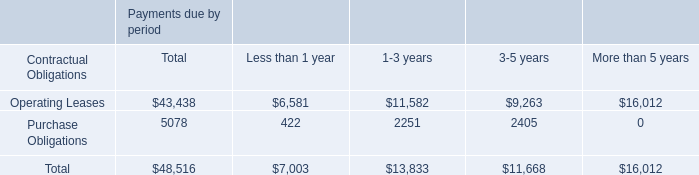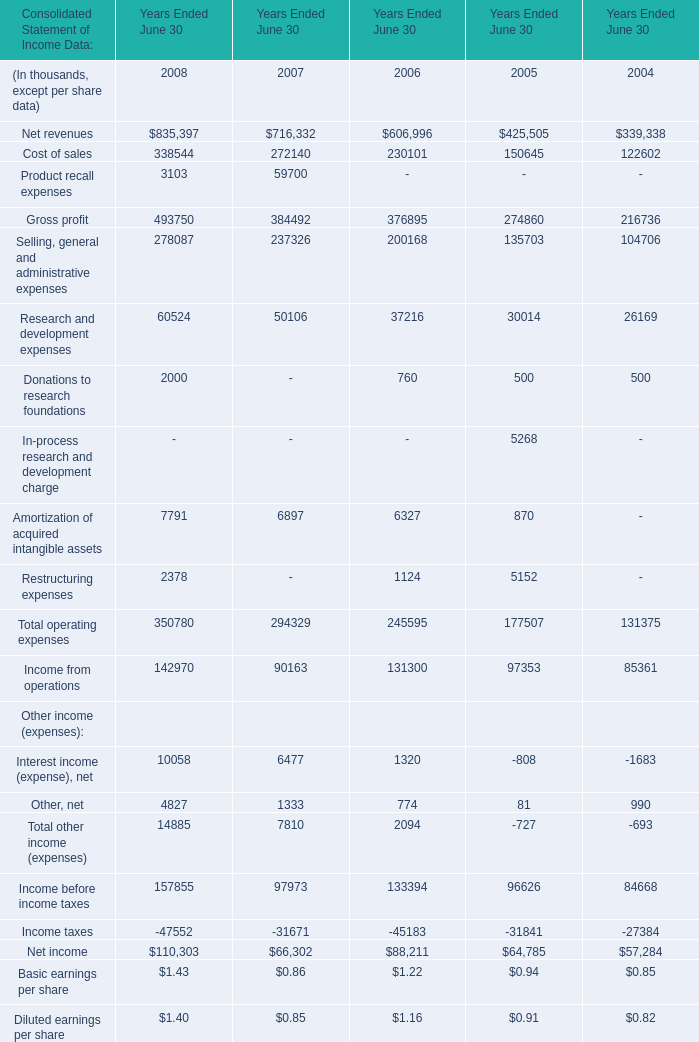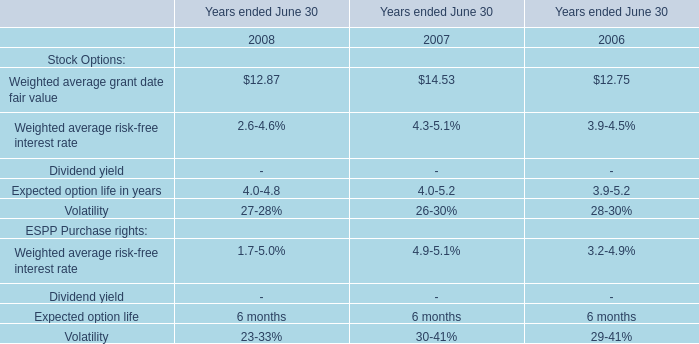In what year is Gross profit greater than 1? 
Answer: 2008 2007 2006 2005 2004. 